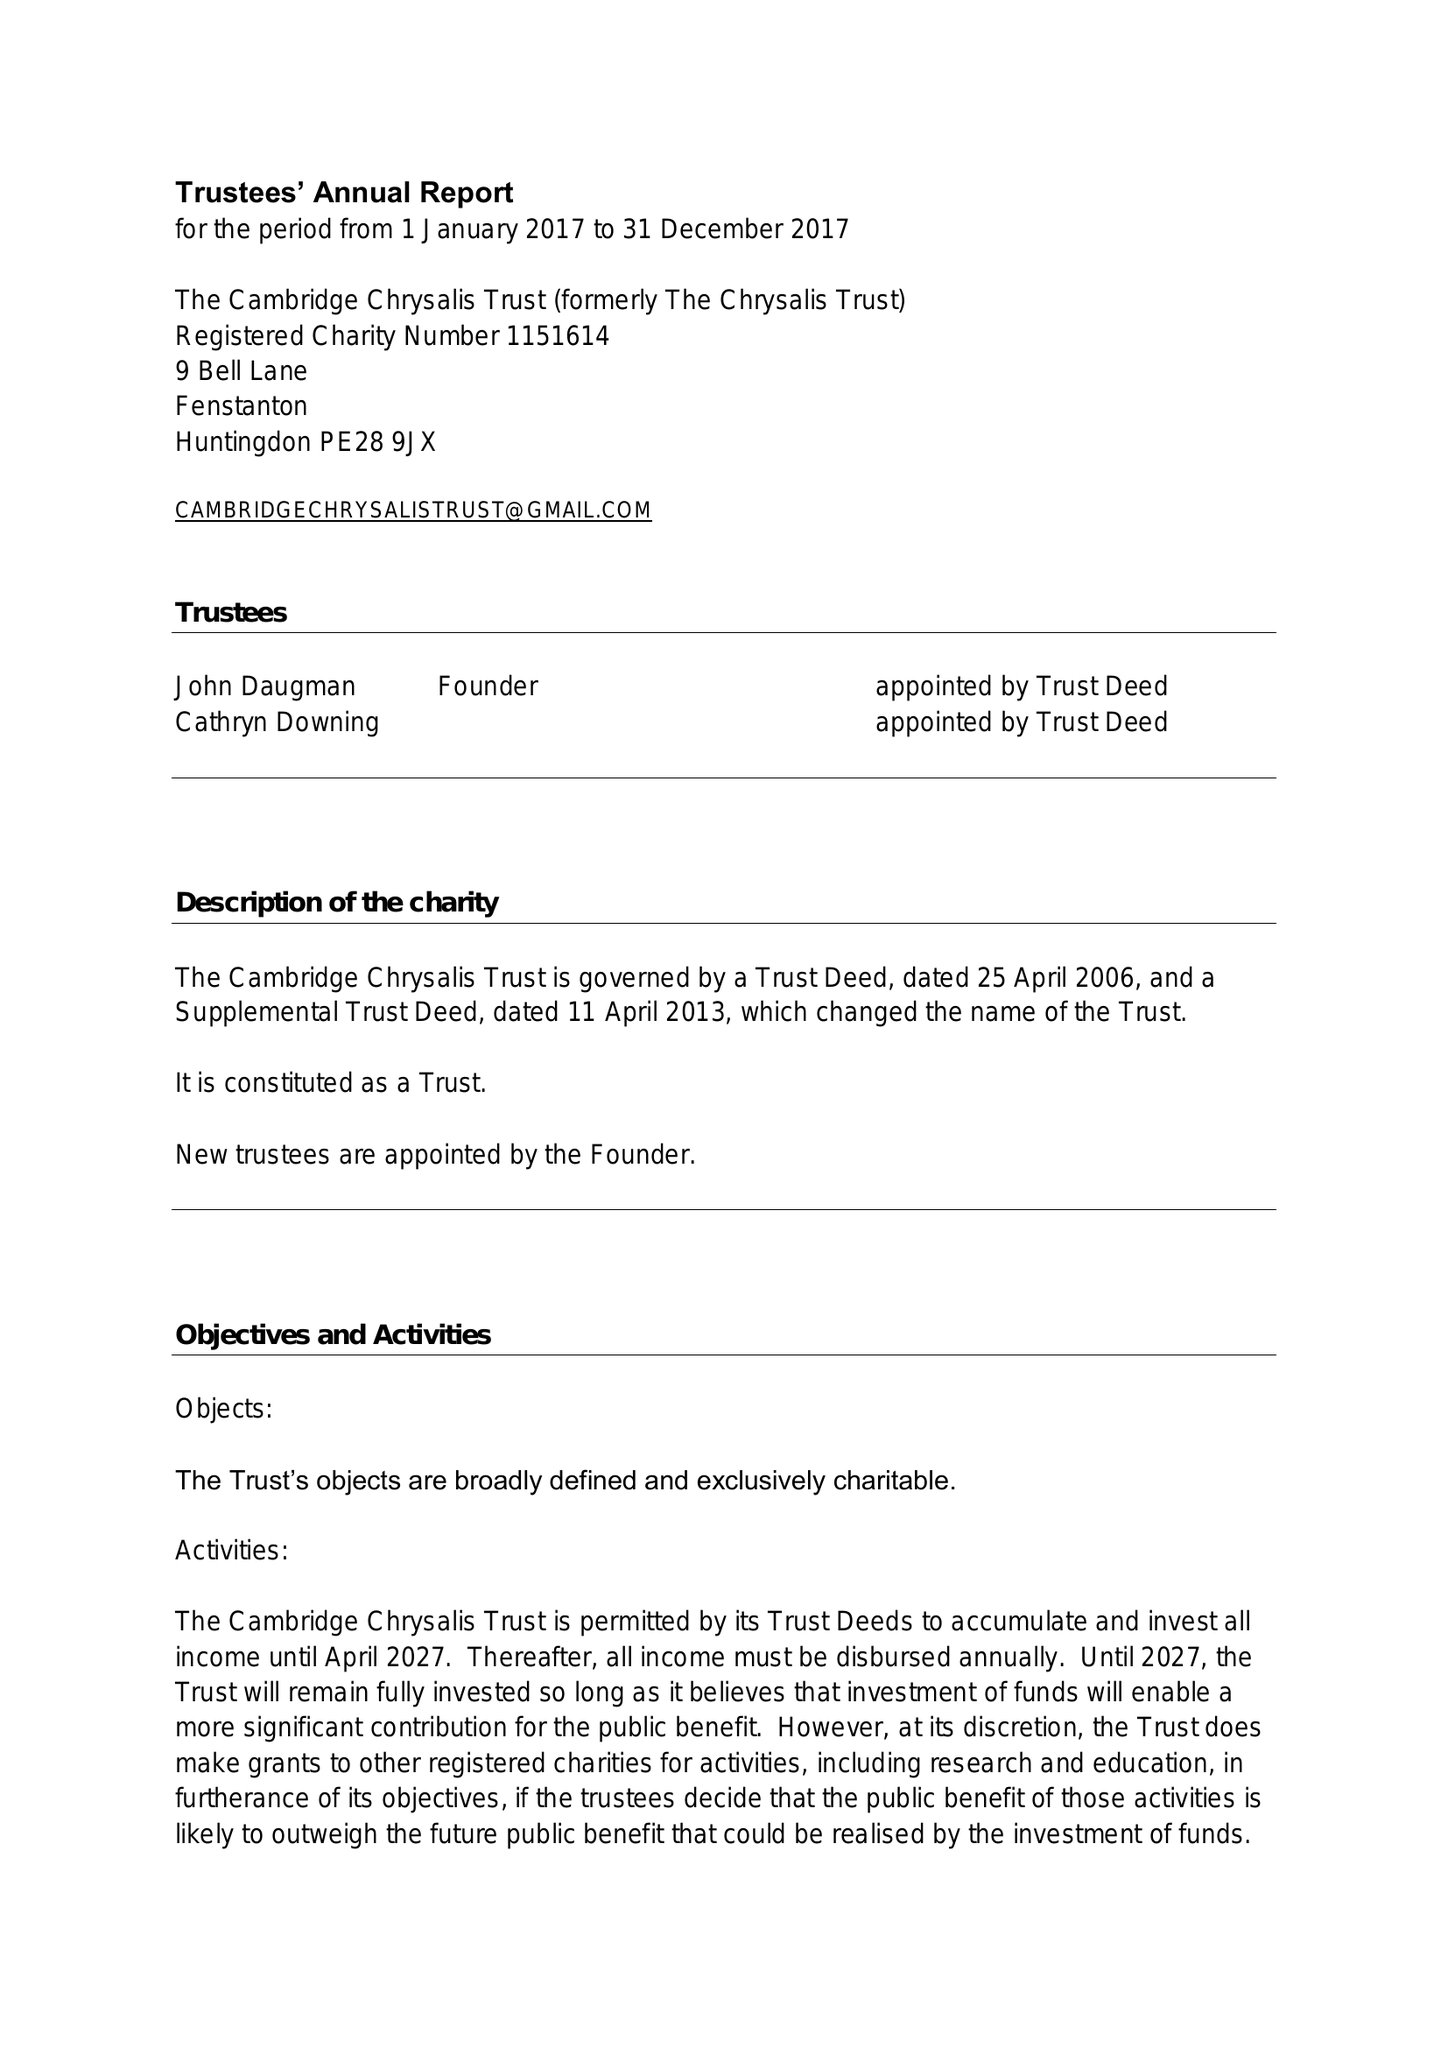What is the value for the charity_number?
Answer the question using a single word or phrase. 1151614 